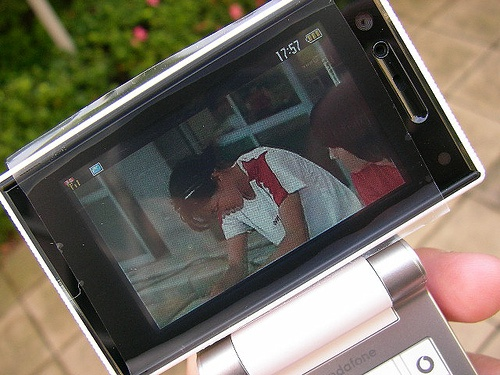Describe the objects in this image and their specific colors. I can see cell phone in black, gray, white, and darkgray tones, people in black, gray, darkgray, and maroon tones, and people in black, lightpink, pink, and salmon tones in this image. 